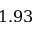Convert formula to latex. <formula><loc_0><loc_0><loc_500><loc_500>1 . 9 3</formula> 